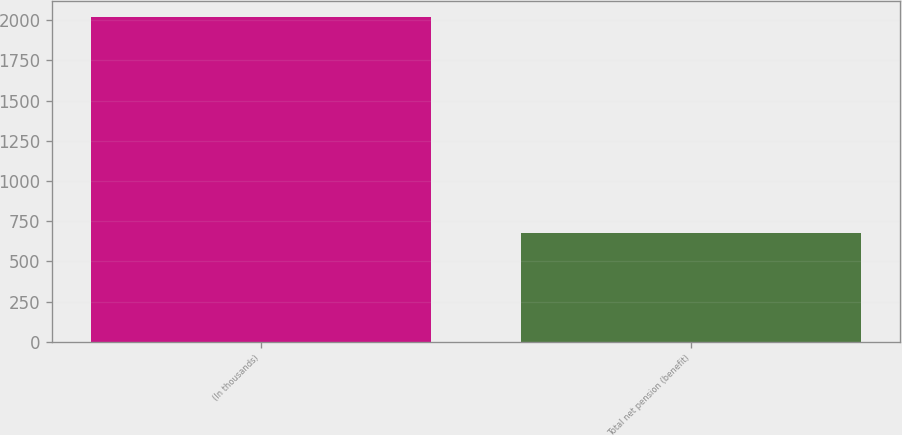Convert chart to OTSL. <chart><loc_0><loc_0><loc_500><loc_500><bar_chart><fcel>(In thousands)<fcel>Total net pension (benefit)<nl><fcel>2018<fcel>675<nl></chart> 